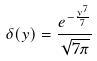<formula> <loc_0><loc_0><loc_500><loc_500>\delta ( y ) = \frac { e ^ { - \frac { y ^ { 7 } } { 7 } } } { \sqrt { 7 \pi } }</formula> 